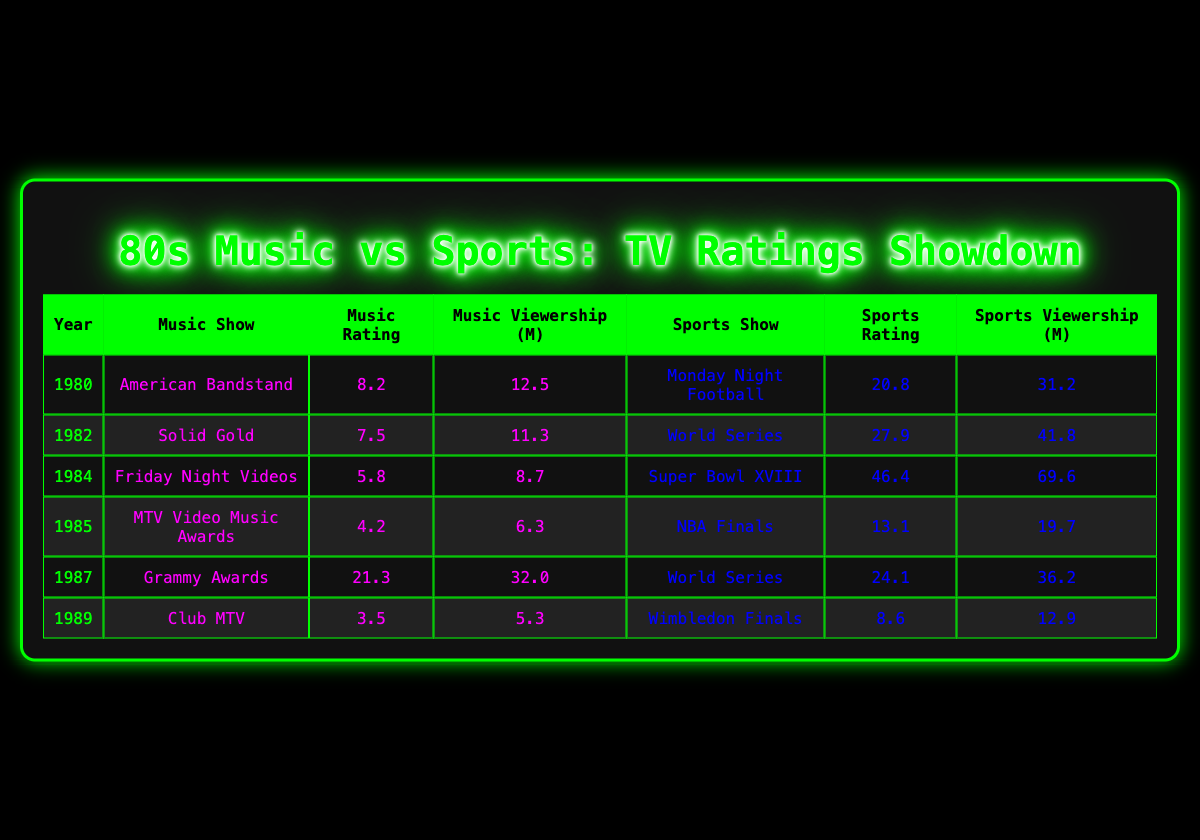What was the highest-rated sports show in the 1980s? Looking at the sports ratings column and identifying the maximum value, the show "Super Bowl XVIII" has the highest rating of 46.4 in 1984.
Answer: Super Bowl XVIII Which music show had the highest viewership? The viewership for "Grammy Awards" in 1987 is 32.0 million, which is higher than all other music show viewerships recorded.
Answer: Grammy Awards What is the average rating of music shows from the data provided? Summing the ratings: (8.2 + 7.5 + 5.8 + 4.2 + 21.3 + 3.5) = 50.5 and dividing by the number of music shows (6), gives an average of 8.42.
Answer: 8.42 Did any music show surpass a rating of 20? The only music show that surpasses a rating of 20 is the "Grammy Awards" with a rating of 21.3. Therefore, the statement is true.
Answer: Yes What is the difference in viewership between the highest-rated sports and music shows? The highest-rated sports show is "Super Bowl XVIII" with 69.6 million viewers and the highest-rated music show is "Grammy Awards" with 32.0 million viewers. The difference is 69.6 - 32.0 = 37.6 million.
Answer: 37.6 million How many sports shows had a viewership of over 30 million? Reviewing the sports viewership numbers, "Monday Night Football" (31.2), "World Series" (41.8), and "Super Bowl XVIII" (69.6) all have viewership over 30 million, totaling three shows.
Answer: 3 Which year had the lowest-rated music show? By examining the ratings for music shows, "MTV Video Music Awards" in 1985 has the lowest rating of 4.2.
Answer: 1985 What was the total viewership for all sports shows combined? Adding the viewership: 31.2 + 41.8 + 69.6 + 19.7 + 36.2 + 12.9 = 211.4 million gives the total viewership for sports shows.
Answer: 211.4 million Was the music viewership for “Club MTV” lower than 10 million? The viewership for "Club MTV" is 5.3 million, which is indeed lower than 10 million. Therefore, the statement is true.
Answer: Yes 